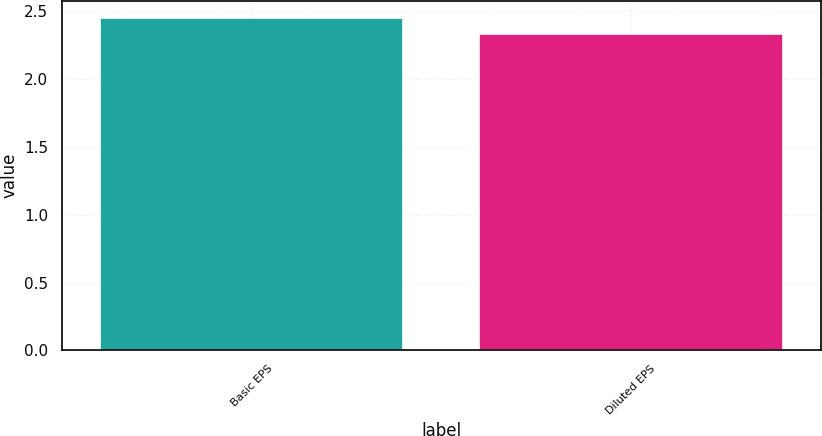Convert chart to OTSL. <chart><loc_0><loc_0><loc_500><loc_500><bar_chart><fcel>Basic EPS<fcel>Diluted EPS<nl><fcel>2.45<fcel>2.33<nl></chart> 